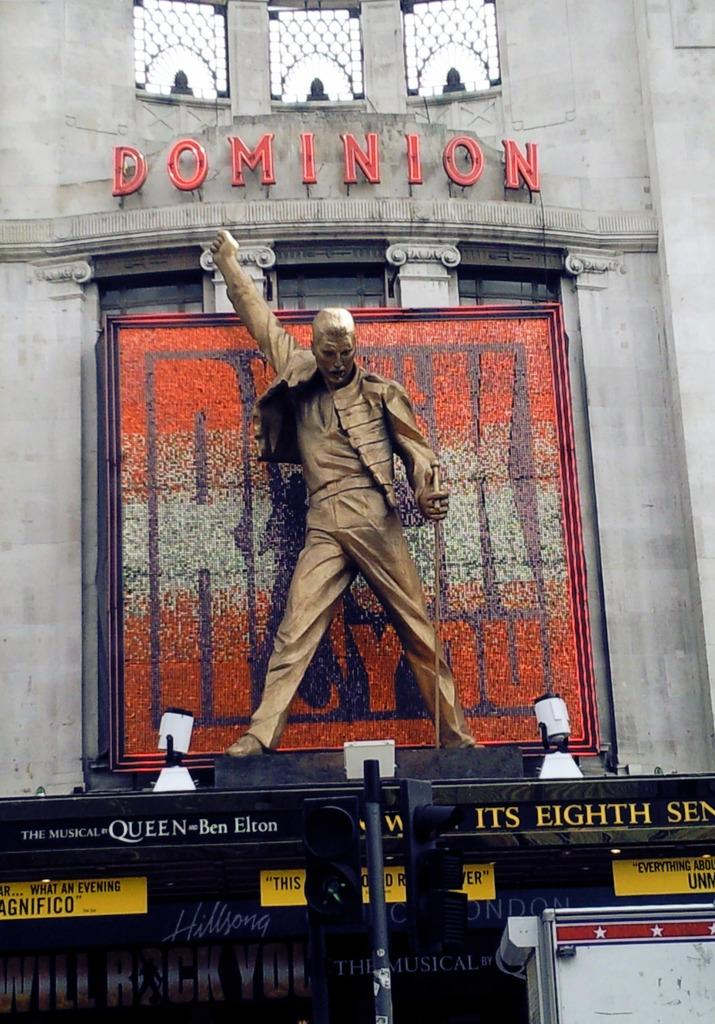<image>
Create a compact narrative representing the image presented. A statue of Freddy Mercury in full flow stands atop the entrance of the Dominican Theatre in London. 